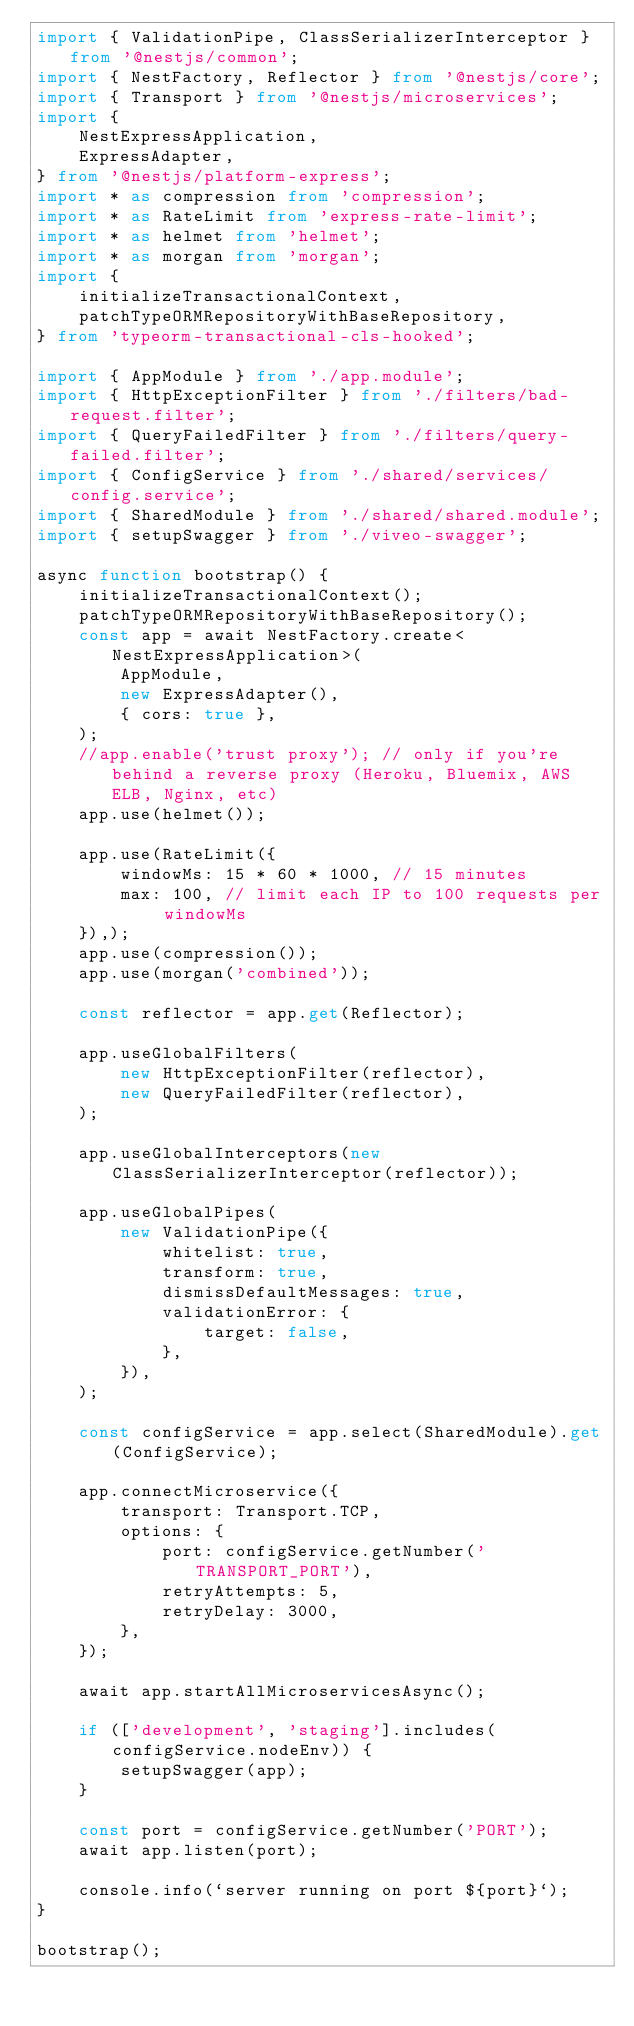Convert code to text. <code><loc_0><loc_0><loc_500><loc_500><_TypeScript_>import { ValidationPipe, ClassSerializerInterceptor } from '@nestjs/common';
import { NestFactory, Reflector } from '@nestjs/core';
import { Transport } from '@nestjs/microservices';
import {
    NestExpressApplication,
    ExpressAdapter,
} from '@nestjs/platform-express';
import * as compression from 'compression';
import * as RateLimit from 'express-rate-limit';
import * as helmet from 'helmet';
import * as morgan from 'morgan';
import {
    initializeTransactionalContext,
    patchTypeORMRepositoryWithBaseRepository,
} from 'typeorm-transactional-cls-hooked';

import { AppModule } from './app.module';
import { HttpExceptionFilter } from './filters/bad-request.filter';
import { QueryFailedFilter } from './filters/query-failed.filter';
import { ConfigService } from './shared/services/config.service';
import { SharedModule } from './shared/shared.module';
import { setupSwagger } from './viveo-swagger';

async function bootstrap() {
    initializeTransactionalContext();
    patchTypeORMRepositoryWithBaseRepository();
    const app = await NestFactory.create<NestExpressApplication>(
        AppModule,
        new ExpressAdapter(),
        { cors: true },
    );
    //app.enable('trust proxy'); // only if you're behind a reverse proxy (Heroku, Bluemix, AWS ELB, Nginx, etc)
    app.use(helmet());

    app.use(RateLimit({
        windowMs: 15 * 60 * 1000, // 15 minutes
        max: 100, // limit each IP to 100 requests per windowMs
    }),);
    app.use(compression());
    app.use(morgan('combined'));

    const reflector = app.get(Reflector);

    app.useGlobalFilters(
        new HttpExceptionFilter(reflector),
        new QueryFailedFilter(reflector),
    );

    app.useGlobalInterceptors(new ClassSerializerInterceptor(reflector));

    app.useGlobalPipes(
        new ValidationPipe({
            whitelist: true,
            transform: true,
            dismissDefaultMessages: true,
            validationError: {
                target: false,
            },
        }),
    );

    const configService = app.select(SharedModule).get(ConfigService);

    app.connectMicroservice({
        transport: Transport.TCP,
        options: {
            port: configService.getNumber('TRANSPORT_PORT'),
            retryAttempts: 5,
            retryDelay: 3000,
        },
    });

    await app.startAllMicroservicesAsync();

    if (['development', 'staging'].includes(configService.nodeEnv)) {
        setupSwagger(app);
    }

    const port = configService.getNumber('PORT');
    await app.listen(port);

    console.info(`server running on port ${port}`);
}

bootstrap();
</code> 